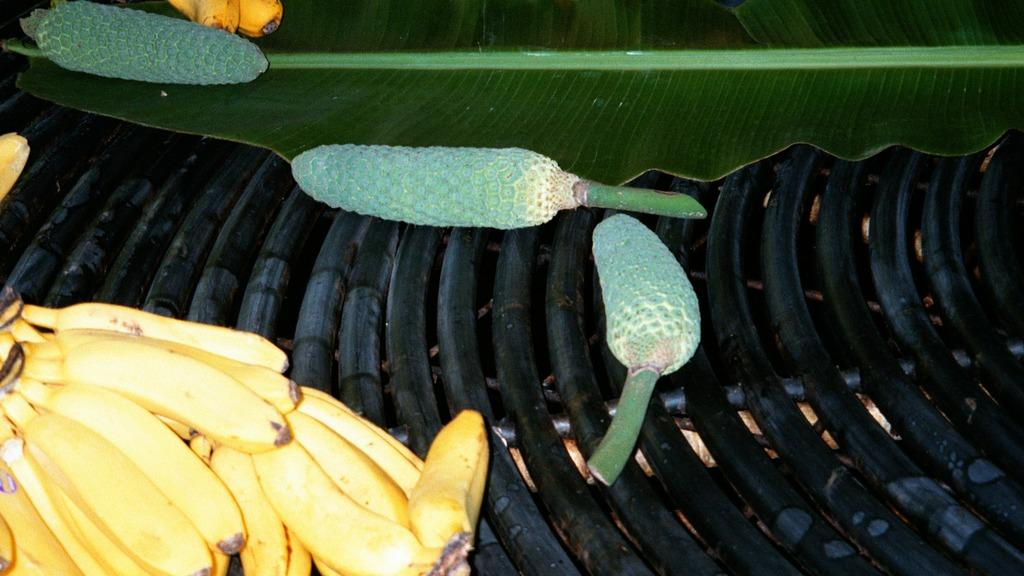What type of plant material is present in the image? There is a leaf in the image. What type of fruit is visible in the image? There are bananas in the image. Are there any other types of fruit in the image besides bananas? Yes, there are other fruits in the image. Can you hear the leaf crying in the image? There is no sound or emotion associated with the leaf in the image, so it cannot be heard crying. 